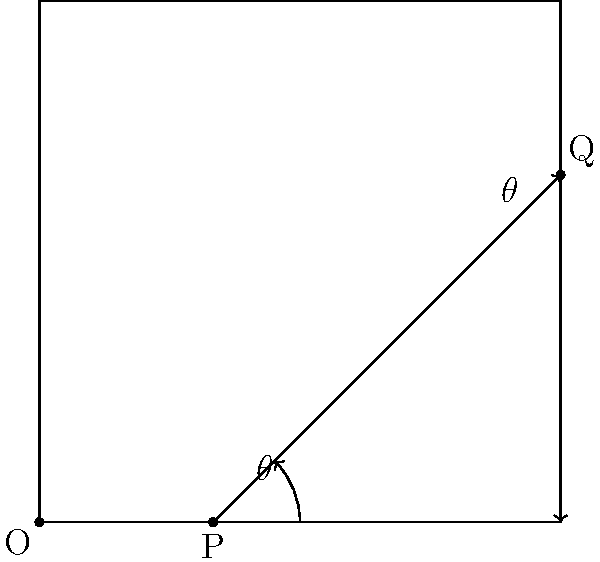In laser-assisted in situ keratomileusis (LASIK) eye surgery, a laser beam is directed at the cornea. If the angle of incidence of the laser beam is $\theta = 30^\circ$, what is the angle between the reflected beam and the surface of the cornea? To solve this problem, we need to apply the law of reflection and our knowledge of complementary angles. Let's break it down step-by-step:

1) The law of reflection states that the angle of incidence is equal to the angle of reflection. In this case, both are $\theta = 30^\circ$.

2) The incident ray, the normal to the surface, and the reflected ray all lie in the same plane.

3) The normal to the surface forms a 90° angle with the surface.

4) The angle of reflection ($30^\circ$) is measured from the normal to the reflected ray.

5) To find the angle between the reflected beam and the surface, we need to subtract the angle of reflection from 90°:

   $90^\circ - 30^\circ = 60^\circ$

6) This is because the angle between the reflected beam and the surface forms a complementary angle with the angle of reflection, and complementary angles add up to 90°.

Therefore, the angle between the reflected beam and the surface of the cornea is 60°.
Answer: $60^\circ$ 